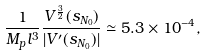Convert formula to latex. <formula><loc_0><loc_0><loc_500><loc_500>\frac { 1 } { M _ { p } l ^ { 3 } } \frac { V ^ { \frac { 3 } { 2 } } ( s _ { N _ { 0 } } ) } { | V ^ { \prime } ( s _ { N _ { 0 } } ) | } \simeq 5 . 3 \times 1 0 ^ { - 4 } ,</formula> 